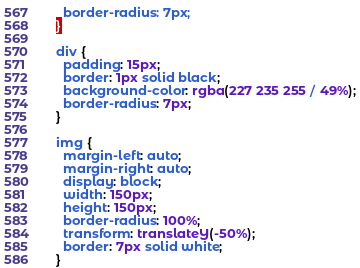Convert code to text. <code><loc_0><loc_0><loc_500><loc_500><_CSS_>  border-radius: 7px;  
}

div {
  padding: 15px;
  border: 1px solid black;
  background-color: rgba(227 235 255 / 49%);
  border-radius: 7px;  
}

img {
  margin-left: auto;
  margin-right: auto;
  display: block;
  width: 150px;
  height: 150px;
  border-radius: 100%;
  transform: translateY(-50%);
  border: 7px solid white;
}
</code> 